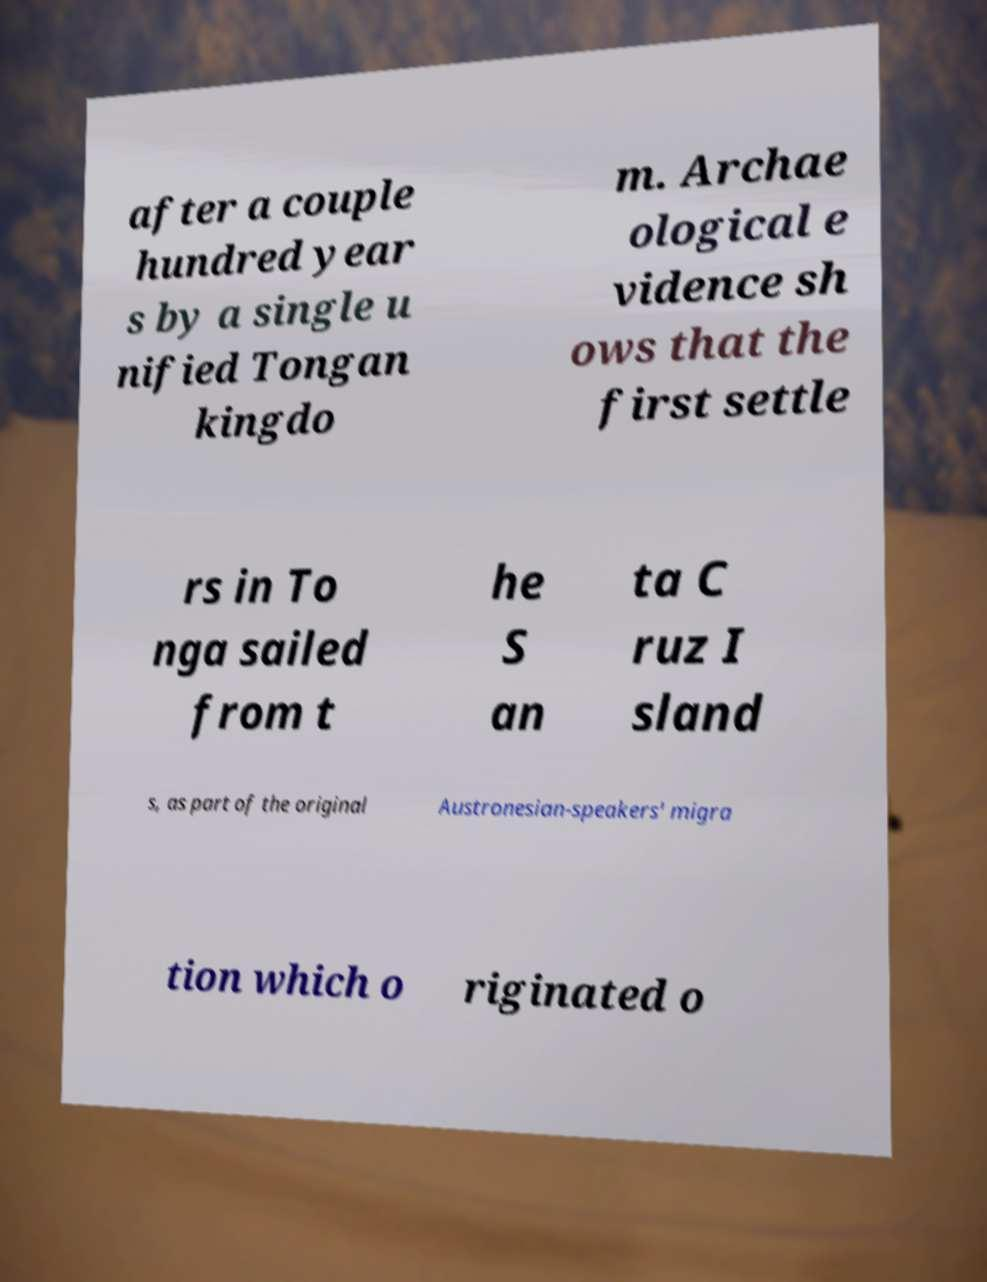What messages or text are displayed in this image? I need them in a readable, typed format. after a couple hundred year s by a single u nified Tongan kingdo m. Archae ological e vidence sh ows that the first settle rs in To nga sailed from t he S an ta C ruz I sland s, as part of the original Austronesian-speakers' migra tion which o riginated o 